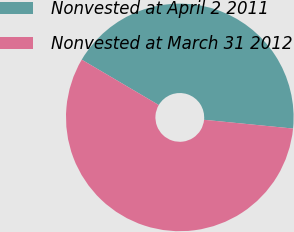Convert chart. <chart><loc_0><loc_0><loc_500><loc_500><pie_chart><fcel>Nonvested at April 2 2011<fcel>Nonvested at March 31 2012<nl><fcel>43.09%<fcel>56.91%<nl></chart> 